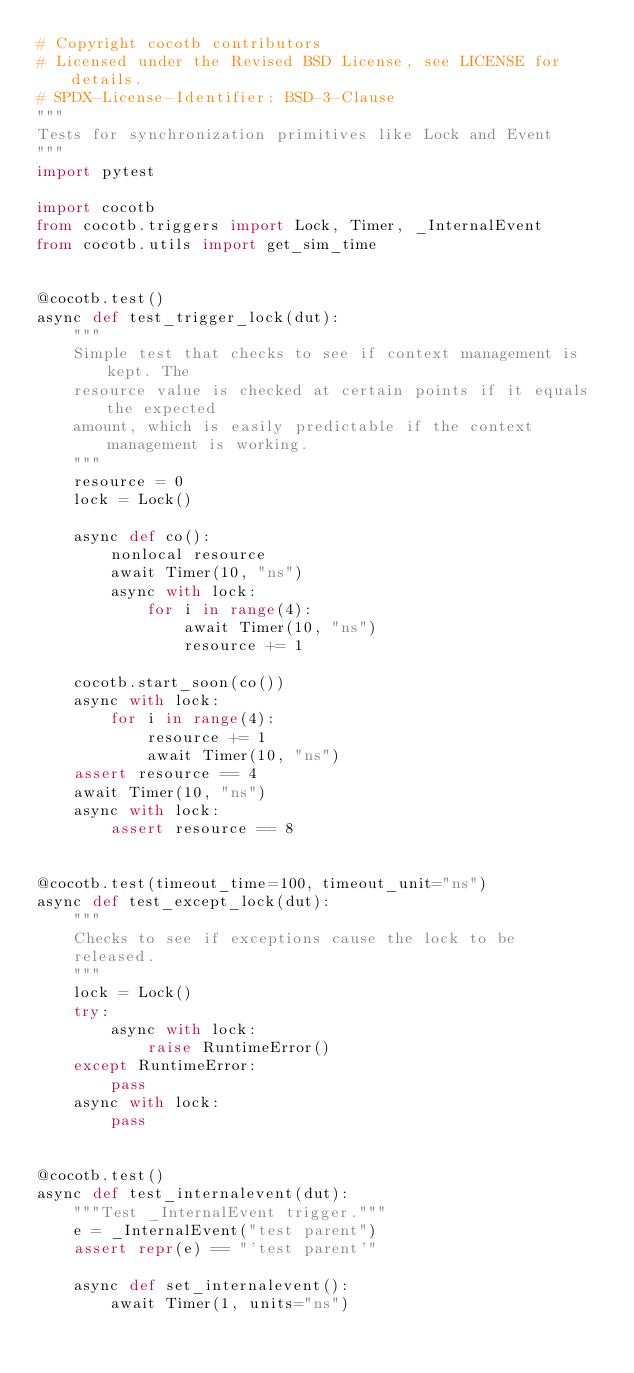Convert code to text. <code><loc_0><loc_0><loc_500><loc_500><_Python_># Copyright cocotb contributors
# Licensed under the Revised BSD License, see LICENSE for details.
# SPDX-License-Identifier: BSD-3-Clause
"""
Tests for synchronization primitives like Lock and Event
"""
import pytest

import cocotb
from cocotb.triggers import Lock, Timer, _InternalEvent
from cocotb.utils import get_sim_time


@cocotb.test()
async def test_trigger_lock(dut):
    """
    Simple test that checks to see if context management is kept. The
    resource value is checked at certain points if it equals the expected
    amount, which is easily predictable if the context management is working.
    """
    resource = 0
    lock = Lock()

    async def co():
        nonlocal resource
        await Timer(10, "ns")
        async with lock:
            for i in range(4):
                await Timer(10, "ns")
                resource += 1

    cocotb.start_soon(co())
    async with lock:
        for i in range(4):
            resource += 1
            await Timer(10, "ns")
    assert resource == 4
    await Timer(10, "ns")
    async with lock:
        assert resource == 8


@cocotb.test(timeout_time=100, timeout_unit="ns")
async def test_except_lock(dut):
    """
    Checks to see if exceptions cause the lock to be
    released.
    """
    lock = Lock()
    try:
        async with lock:
            raise RuntimeError()
    except RuntimeError:
        pass
    async with lock:
        pass


@cocotb.test()
async def test_internalevent(dut):
    """Test _InternalEvent trigger."""
    e = _InternalEvent("test parent")
    assert repr(e) == "'test parent'"

    async def set_internalevent():
        await Timer(1, units="ns")</code> 